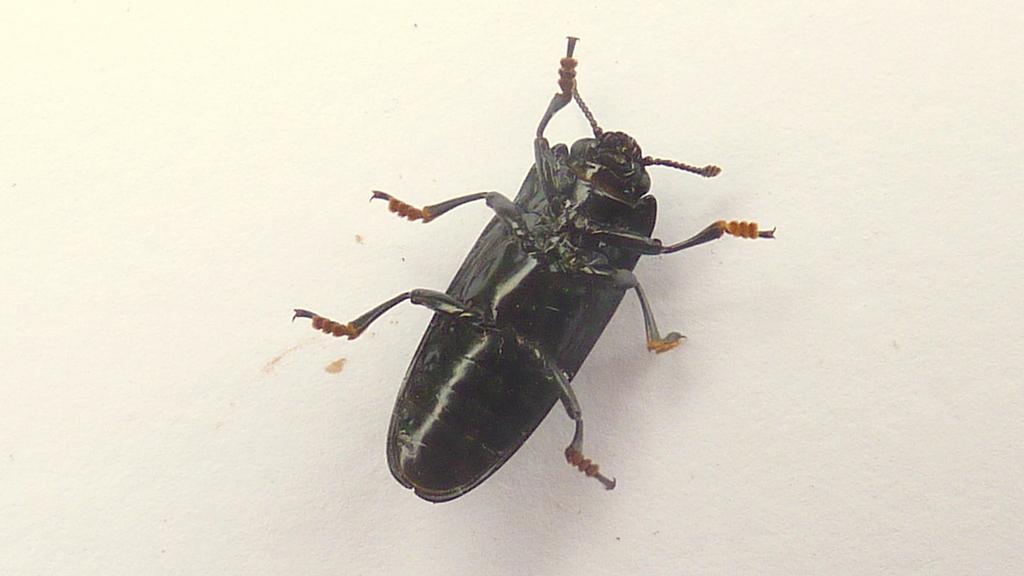How would you summarize this image in a sentence or two? We can see insect on white surface. 